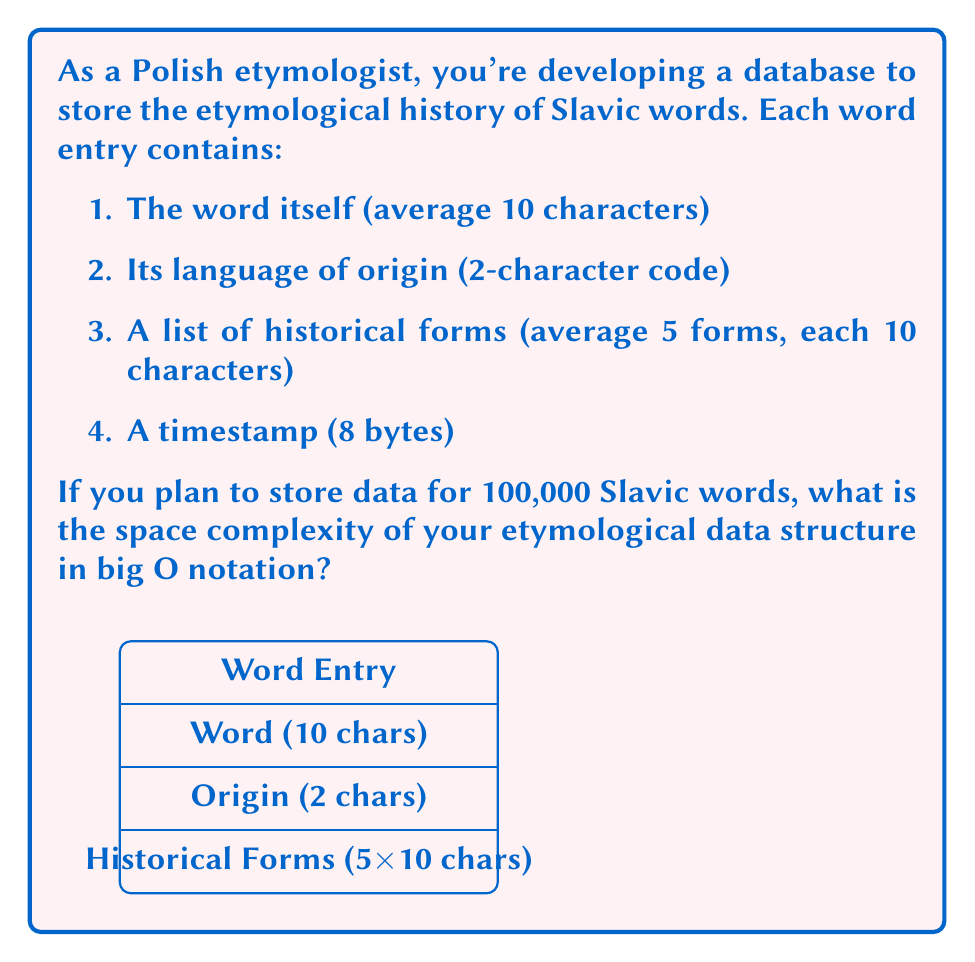What is the answer to this math problem? Let's break down the space requirements for each component of a word entry:

1. Word: 10 characters * 1 byte/character = 10 bytes
2. Language of origin: 2 characters * 1 byte/character = 2 bytes
3. Historical forms: 5 forms * 10 characters/form * 1 byte/character = 50 bytes
4. Timestamp: 8 bytes

Total space per word entry: $10 + 2 + 50 + 8 = 70$ bytes

Now, let's consider the space complexity for storing 100,000 words:

$$ \text{Total Space} = 100,000 \times 70 \text{ bytes} = 7,000,000 \text{ bytes} $$

In big O notation, we express this as $O(n)$, where $n$ is the number of words. This is because the space required grows linearly with the number of word entries.

The constant factors (70 bytes per entry) are dropped in big O notation, as we're interested in the growth rate, not the exact size. Therefore, regardless of the specific size of each entry, the space complexity remains $O(n)$.
Answer: $O(n)$ 